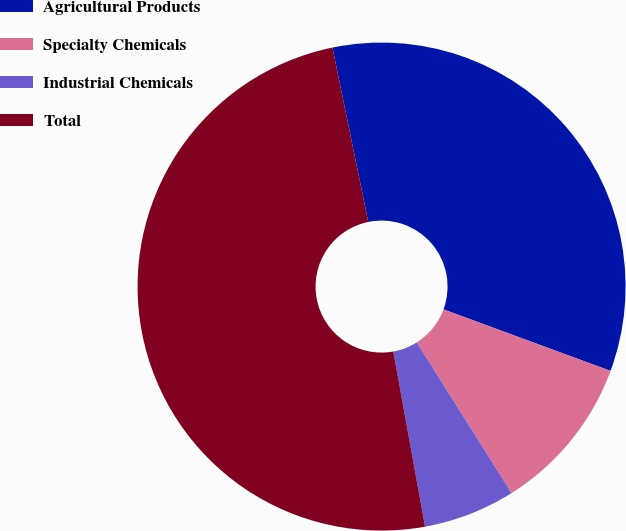Convert chart to OTSL. <chart><loc_0><loc_0><loc_500><loc_500><pie_chart><fcel>Agricultural Products<fcel>Specialty Chemicals<fcel>Industrial Chemicals<fcel>Total<nl><fcel>33.84%<fcel>10.44%<fcel>6.09%<fcel>49.62%<nl></chart> 